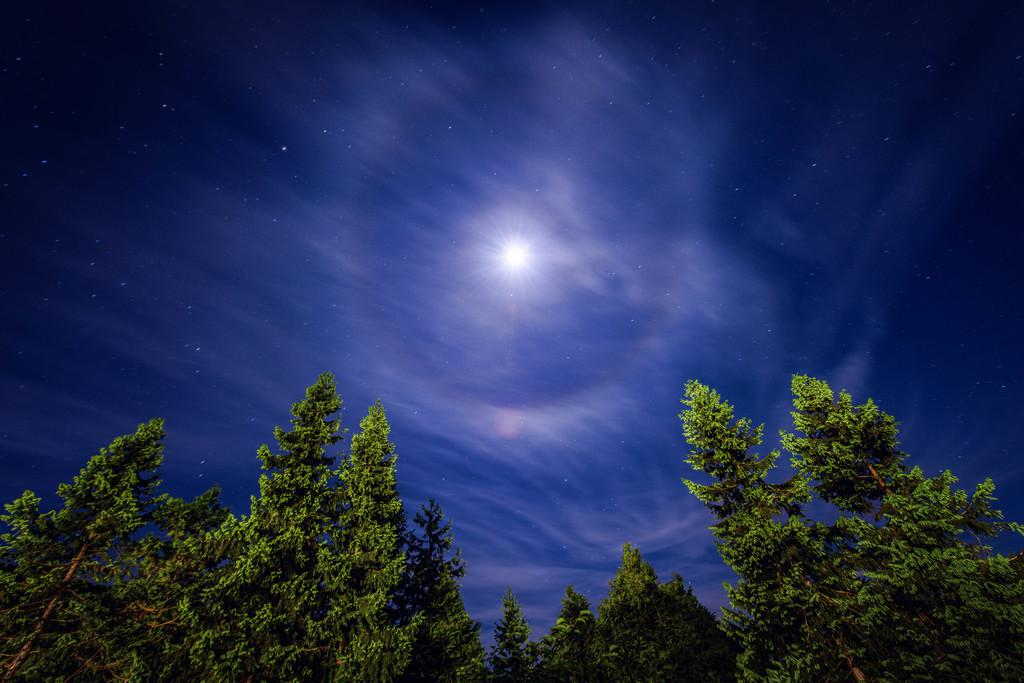What type of vegetation can be seen in the image? There are trees in the image, extending from left to right. What can be seen in the sky in the image? There is a light in the sky. What type of feather can be seen in the wilderness in the image? There is no feather or wilderness present in the image; it only features trees and a light in the sky. 